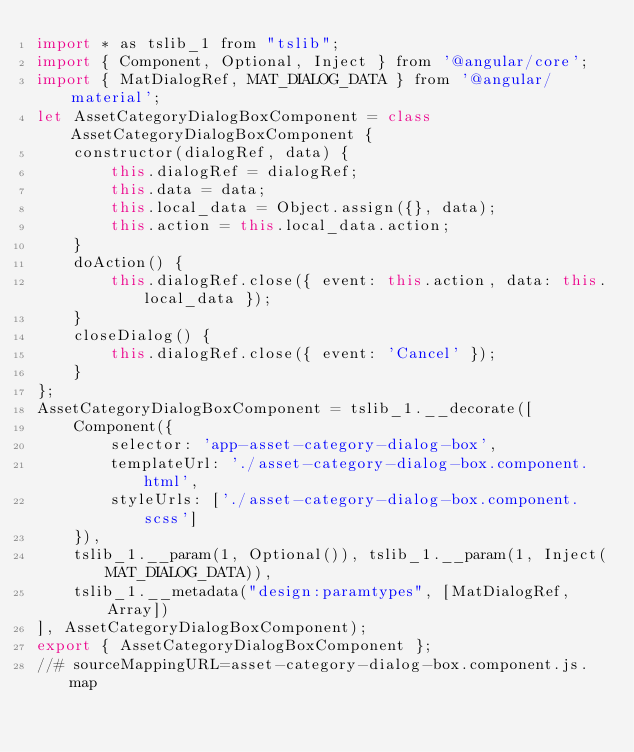<code> <loc_0><loc_0><loc_500><loc_500><_JavaScript_>import * as tslib_1 from "tslib";
import { Component, Optional, Inject } from '@angular/core';
import { MatDialogRef, MAT_DIALOG_DATA } from '@angular/material';
let AssetCategoryDialogBoxComponent = class AssetCategoryDialogBoxComponent {
    constructor(dialogRef, data) {
        this.dialogRef = dialogRef;
        this.data = data;
        this.local_data = Object.assign({}, data);
        this.action = this.local_data.action;
    }
    doAction() {
        this.dialogRef.close({ event: this.action, data: this.local_data });
    }
    closeDialog() {
        this.dialogRef.close({ event: 'Cancel' });
    }
};
AssetCategoryDialogBoxComponent = tslib_1.__decorate([
    Component({
        selector: 'app-asset-category-dialog-box',
        templateUrl: './asset-category-dialog-box.component.html',
        styleUrls: ['./asset-category-dialog-box.component.scss']
    }),
    tslib_1.__param(1, Optional()), tslib_1.__param(1, Inject(MAT_DIALOG_DATA)),
    tslib_1.__metadata("design:paramtypes", [MatDialogRef, Array])
], AssetCategoryDialogBoxComponent);
export { AssetCategoryDialogBoxComponent };
//# sourceMappingURL=asset-category-dialog-box.component.js.map</code> 